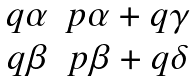Convert formula to latex. <formula><loc_0><loc_0><loc_500><loc_500>\begin{matrix} q \alpha & p \alpha + q \gamma \\ q \beta & p \beta + q \delta \end{matrix}</formula> 